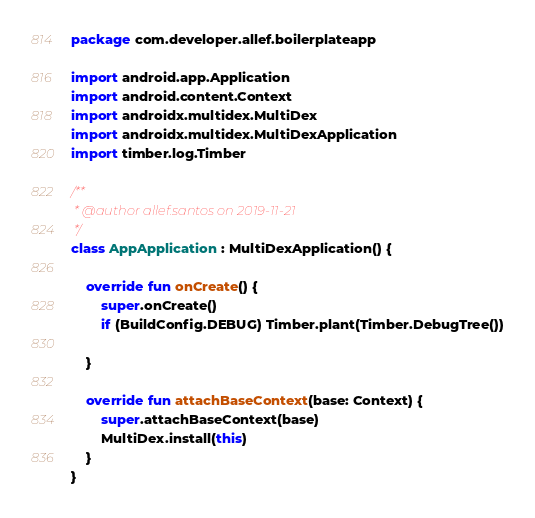<code> <loc_0><loc_0><loc_500><loc_500><_Kotlin_>package com.developer.allef.boilerplateapp

import android.app.Application
import android.content.Context
import androidx.multidex.MultiDex
import androidx.multidex.MultiDexApplication
import timber.log.Timber

/**
 * @author allef.santos on 2019-11-21
 */
class AppApplication : MultiDexApplication() {

    override fun onCreate() {
        super.onCreate()
        if (BuildConfig.DEBUG) Timber.plant(Timber.DebugTree())

    }

    override fun attachBaseContext(base: Context) {
        super.attachBaseContext(base)
        MultiDex.install(this)
    }
}</code> 